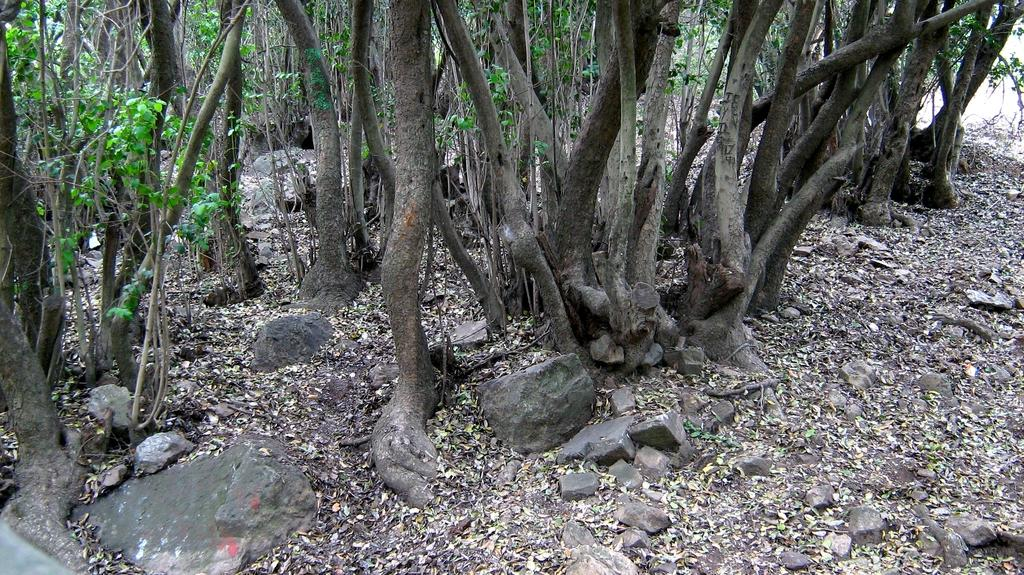What type of vegetation can be seen in the image? There are trees in the image. What other objects can be seen on the ground in the image? There are stones in the image. What else is present on the ground in the image? Dried leaves are present in the image. What type of coil can be seen in the image? There is no coil present in the image. Is the grandfather sitting under the tree in the image? There is no mention of a grandfather or any person in the image; it only features trees, stones, and dried leaves. 